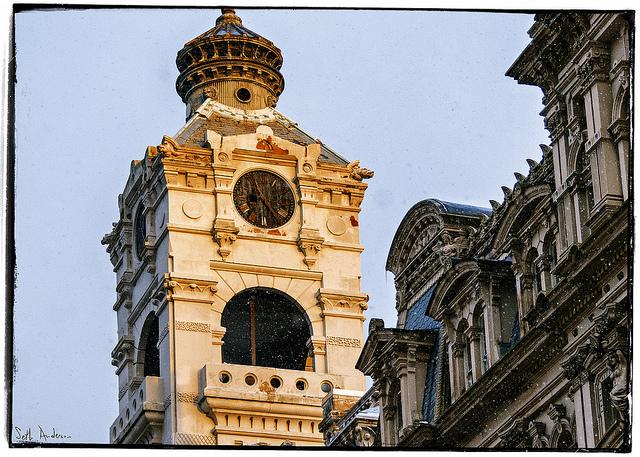What is shown on the tower?
Keep it brief. Clock. Does this architecture resemble the Old Executive Office Building?
Be succinct. Yes. Could the time be 11:25 PM?
Be succinct. Yes. 